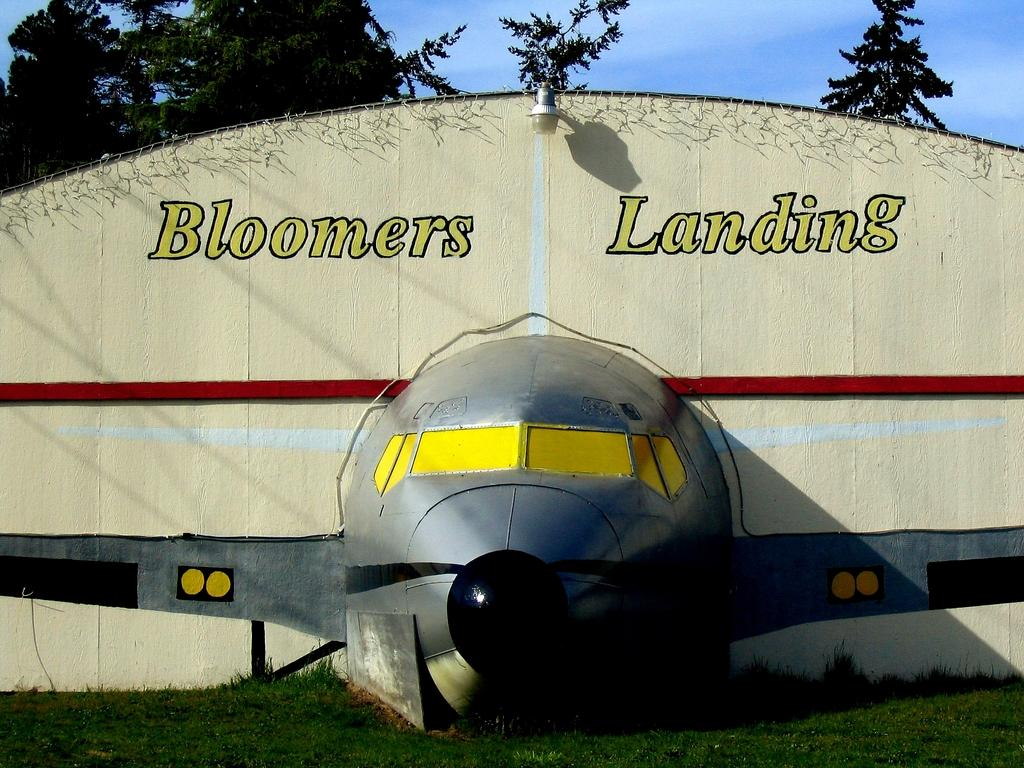<image>
Relay a brief, clear account of the picture shown. A model of an airplane decorates the walls of the Bloomers Landing hangar. 